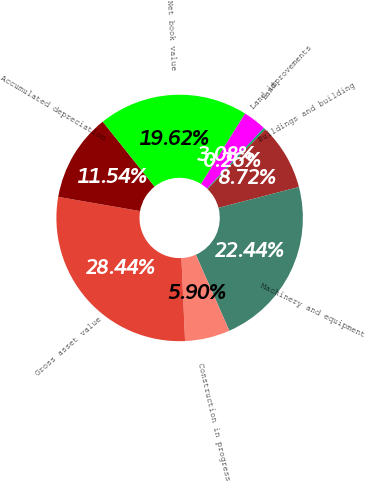Convert chart to OTSL. <chart><loc_0><loc_0><loc_500><loc_500><pie_chart><fcel>Land<fcel>Land improvements<fcel>Buildings and building<fcel>Machinery and equipment<fcel>Construction in progress<fcel>Gross asset value<fcel>Accumulated depreciation<fcel>Net book value<nl><fcel>3.08%<fcel>0.26%<fcel>8.72%<fcel>22.44%<fcel>5.9%<fcel>28.44%<fcel>11.54%<fcel>19.62%<nl></chart> 